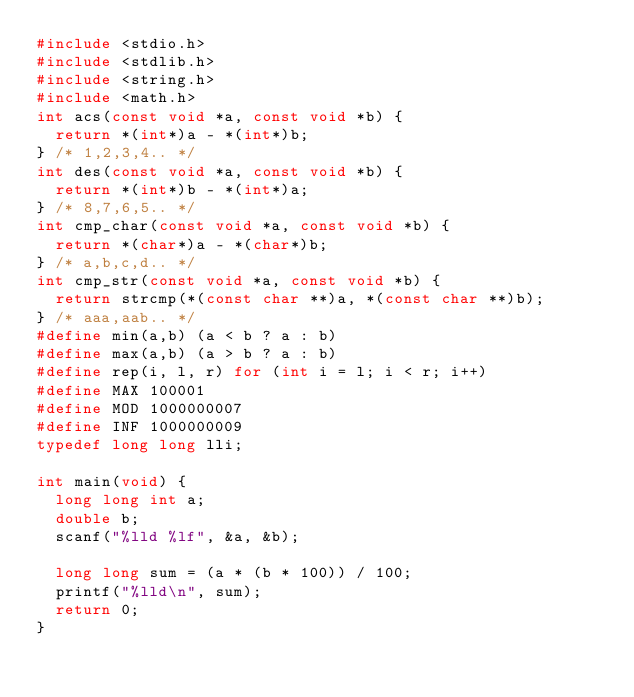<code> <loc_0><loc_0><loc_500><loc_500><_C_>#include <stdio.h>
#include <stdlib.h>
#include <string.h>
#include <math.h>
int acs(const void *a, const void *b) { 
  return *(int*)a - *(int*)b;
} /* 1,2,3,4.. */
int des(const void *a, const void *b) {
  return *(int*)b - *(int*)a;
} /* 8,7,6,5.. */
int cmp_char(const void *a, const void *b) { 
  return *(char*)a - *(char*)b;
} /* a,b,c,d.. */
int cmp_str(const void *a, const void *b) {
  return strcmp(*(const char **)a, *(const char **)b);
} /* aaa,aab.. */
#define min(a,b) (a < b ? a : b)
#define max(a,b) (a > b ? a : b)
#define rep(i, l, r) for (int i = l; i < r; i++)
#define MAX 100001
#define MOD 1000000007
#define INF 1000000009
typedef long long lli;

int main(void) {
  long long int a;
  double b;
  scanf("%lld %lf", &a, &b);

  long long sum = (a * (b * 100)) / 100; 
  printf("%lld\n", sum);
  return 0;
}
</code> 